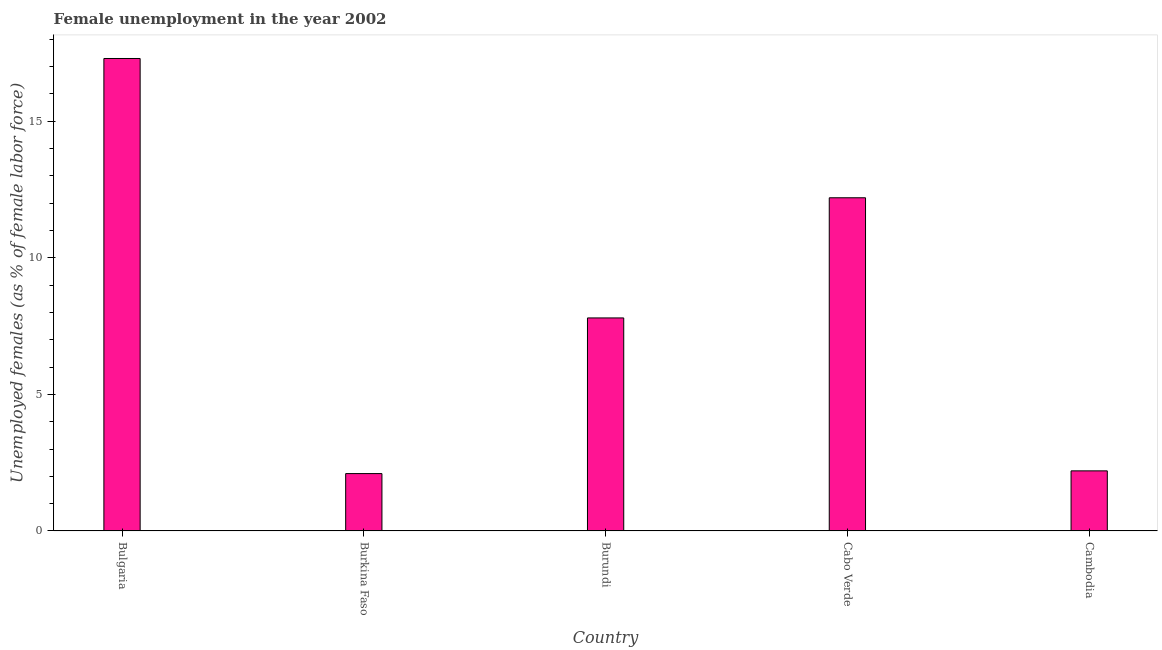Does the graph contain any zero values?
Keep it short and to the point. No. Does the graph contain grids?
Offer a very short reply. No. What is the title of the graph?
Your answer should be very brief. Female unemployment in the year 2002. What is the label or title of the Y-axis?
Offer a terse response. Unemployed females (as % of female labor force). What is the unemployed females population in Cambodia?
Offer a terse response. 2.2. Across all countries, what is the maximum unemployed females population?
Keep it short and to the point. 17.3. Across all countries, what is the minimum unemployed females population?
Your answer should be compact. 2.1. In which country was the unemployed females population maximum?
Offer a terse response. Bulgaria. In which country was the unemployed females population minimum?
Offer a terse response. Burkina Faso. What is the sum of the unemployed females population?
Offer a terse response. 41.6. What is the average unemployed females population per country?
Offer a very short reply. 8.32. What is the median unemployed females population?
Keep it short and to the point. 7.8. In how many countries, is the unemployed females population greater than 1 %?
Provide a succinct answer. 5. What is the ratio of the unemployed females population in Bulgaria to that in Burundi?
Provide a succinct answer. 2.22. What is the difference between the highest and the second highest unemployed females population?
Offer a very short reply. 5.1. In how many countries, is the unemployed females population greater than the average unemployed females population taken over all countries?
Provide a short and direct response. 2. What is the difference between two consecutive major ticks on the Y-axis?
Give a very brief answer. 5. Are the values on the major ticks of Y-axis written in scientific E-notation?
Offer a terse response. No. What is the Unemployed females (as % of female labor force) in Bulgaria?
Offer a very short reply. 17.3. What is the Unemployed females (as % of female labor force) in Burkina Faso?
Provide a short and direct response. 2.1. What is the Unemployed females (as % of female labor force) of Burundi?
Provide a succinct answer. 7.8. What is the Unemployed females (as % of female labor force) in Cabo Verde?
Keep it short and to the point. 12.2. What is the Unemployed females (as % of female labor force) of Cambodia?
Your answer should be compact. 2.2. What is the difference between the Unemployed females (as % of female labor force) in Bulgaria and Burkina Faso?
Keep it short and to the point. 15.2. What is the difference between the Unemployed females (as % of female labor force) in Bulgaria and Cabo Verde?
Provide a short and direct response. 5.1. What is the difference between the Unemployed females (as % of female labor force) in Burkina Faso and Burundi?
Offer a very short reply. -5.7. What is the difference between the Unemployed females (as % of female labor force) in Burkina Faso and Cambodia?
Offer a terse response. -0.1. What is the difference between the Unemployed females (as % of female labor force) in Burundi and Cabo Verde?
Provide a succinct answer. -4.4. What is the difference between the Unemployed females (as % of female labor force) in Cabo Verde and Cambodia?
Provide a succinct answer. 10. What is the ratio of the Unemployed females (as % of female labor force) in Bulgaria to that in Burkina Faso?
Provide a short and direct response. 8.24. What is the ratio of the Unemployed females (as % of female labor force) in Bulgaria to that in Burundi?
Offer a very short reply. 2.22. What is the ratio of the Unemployed females (as % of female labor force) in Bulgaria to that in Cabo Verde?
Your answer should be very brief. 1.42. What is the ratio of the Unemployed females (as % of female labor force) in Bulgaria to that in Cambodia?
Ensure brevity in your answer.  7.86. What is the ratio of the Unemployed females (as % of female labor force) in Burkina Faso to that in Burundi?
Your answer should be very brief. 0.27. What is the ratio of the Unemployed females (as % of female labor force) in Burkina Faso to that in Cabo Verde?
Provide a succinct answer. 0.17. What is the ratio of the Unemployed females (as % of female labor force) in Burkina Faso to that in Cambodia?
Provide a short and direct response. 0.95. What is the ratio of the Unemployed females (as % of female labor force) in Burundi to that in Cabo Verde?
Provide a short and direct response. 0.64. What is the ratio of the Unemployed females (as % of female labor force) in Burundi to that in Cambodia?
Provide a short and direct response. 3.54. What is the ratio of the Unemployed females (as % of female labor force) in Cabo Verde to that in Cambodia?
Provide a succinct answer. 5.54. 